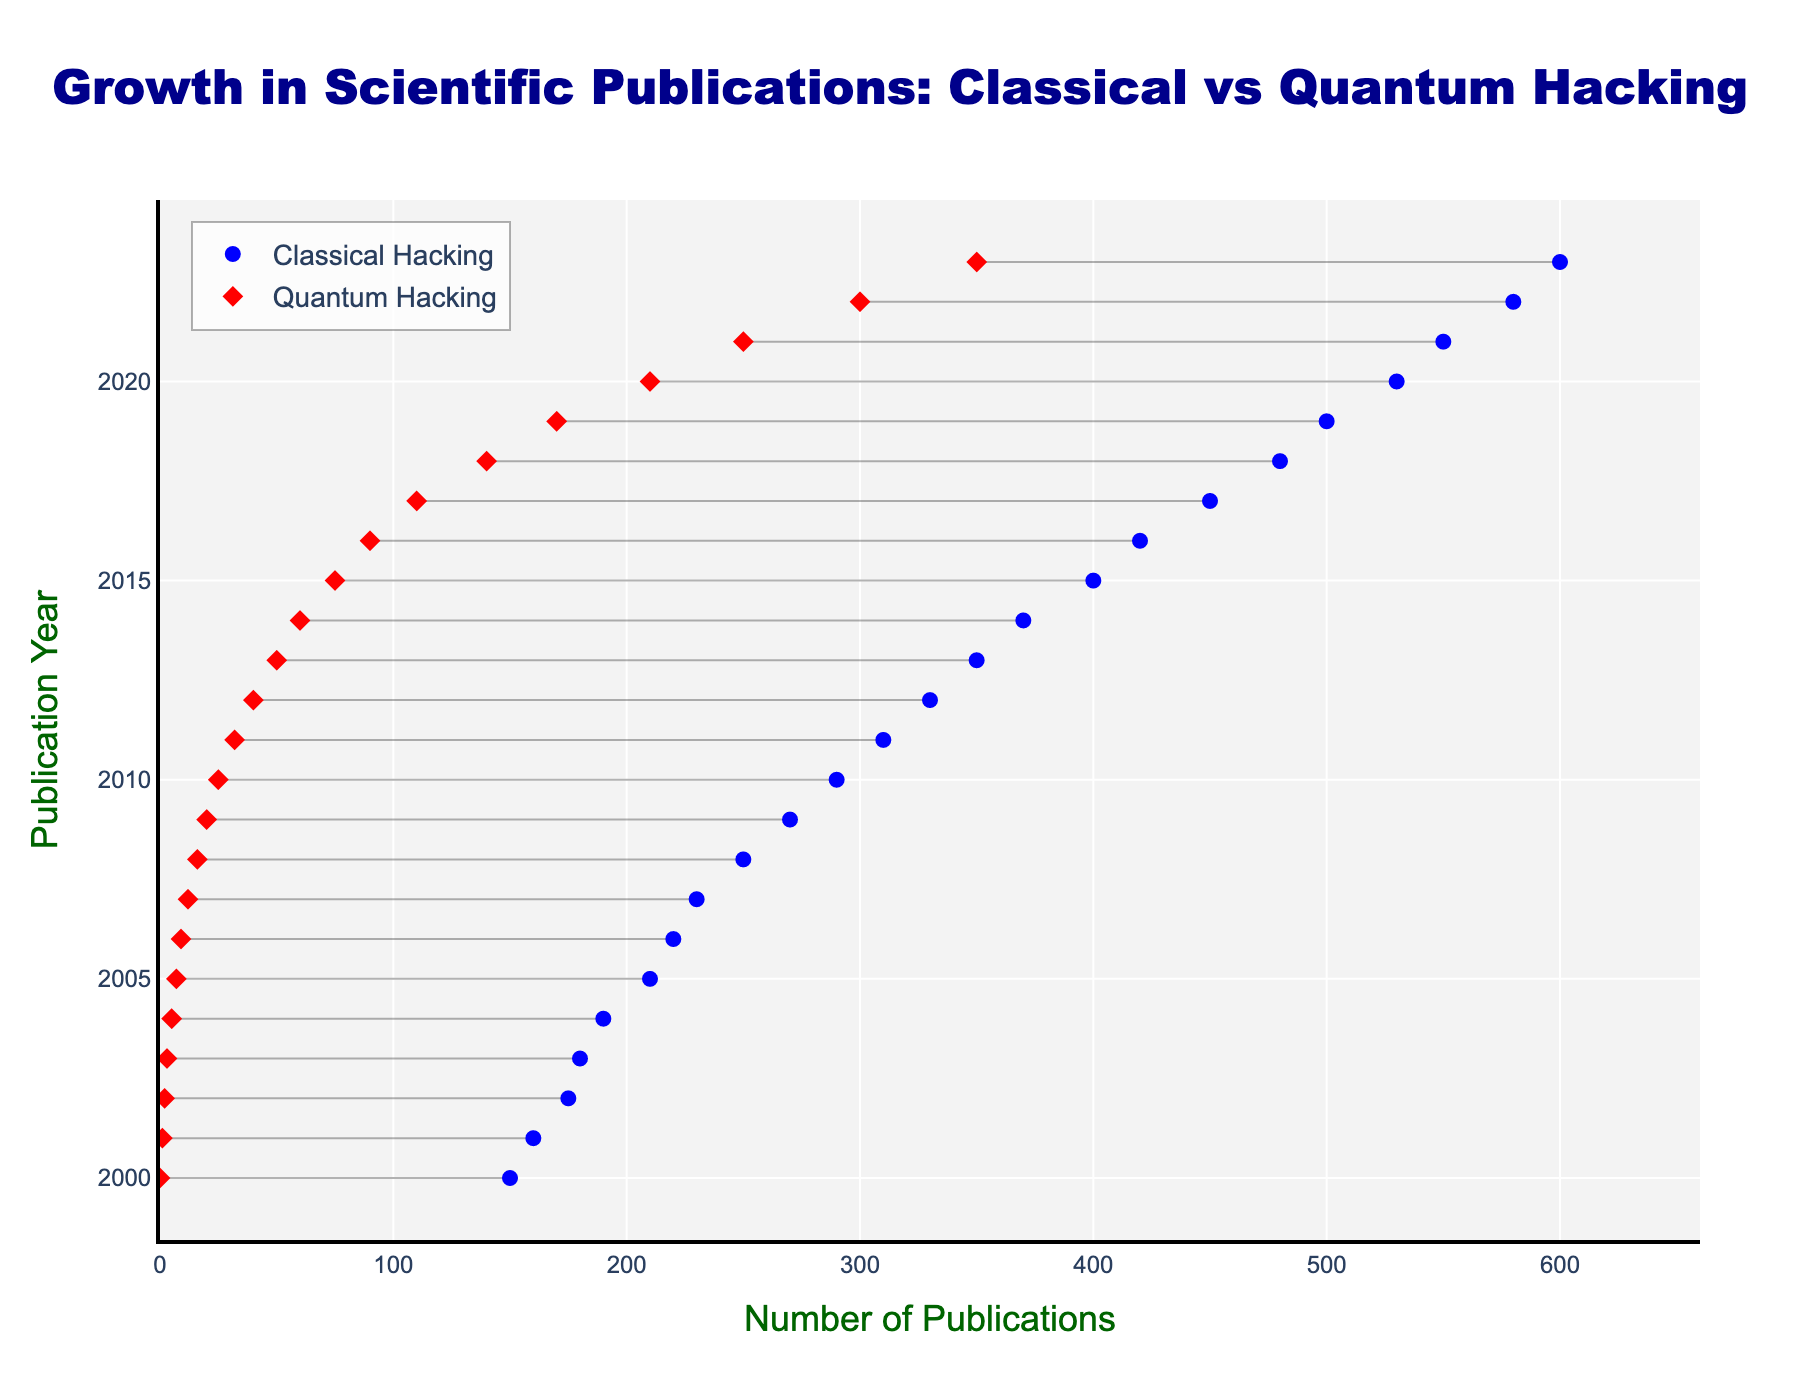What is the title of the figure? The title is displayed at the top center of the figure. It provides a summary of what the figure is about.
Answer: Growth in Scientific Publications: Classical vs Quantum Hacking How many data points are there for each hacking technique? The figure shows data points for each year from 2000 to 2023.
Answer: 24 What color represents 'Quantum Hacking' in the marker legends? The legend in the figure indicates the color associated with each category. The color for 'Quantum Hacking' is identified as red.
Answer: Red Which year saw the highest number of publications for classical hacking techniques? Looking at the dumbbell plot, the rightmost point of the 'Classical Hacking' markers represents the highest value. This occurs in the year 2023.
Answer: 2023 By how much did the number of classical hacking publications increase from 2000 to 2023? Subtract the number of publications in 2000 from those in 2023. From the figure, 600 (in 2023) - 150 (in 2000) = 450.
Answer: 450 What is the publication trend for quantum hacking techniques between 2000 and 2023? Observing the red markers from left (2000) to right (2023), the number of publications is consistently increasing, indicating an upward trend.
Answer: Increasing How does the publication growth rate of quantum hacking compare to classical hacking from 2010 to 2023? Compute the differences from 2010 to 2023 for each. For classical: 600 - 290 = 310. For quantum: 350 - 25 = 325. Quantum hacking publications grew slightly more over this period.
Answer: Quantum hacking grew more In which year did the number of quantum hacking publications surpass 100? Locate the red marker that crosses the 100-publication mark on the x-axis. This occurs around the year 2017.
Answer: 2017 What percentage of total publications in 2023 are related to quantum hacking? Total publications for 2023 are the sum of classical and quantum: 600 (classical) + 350 (quantum) = 950. Quantum's percentage is (350 / 950) * 100 = 36.84.
Answer: 36.84% What is the average annual increase in quantum hacking publications between 2000 and 2023? Calculate the total increase and then divide by the number of years. Total increase: 350 - 0 = 350. Number of years: 2023 - 2000 = 23. Average increase: 350 / 23 ≈ 15.22.
Answer: 15.22 